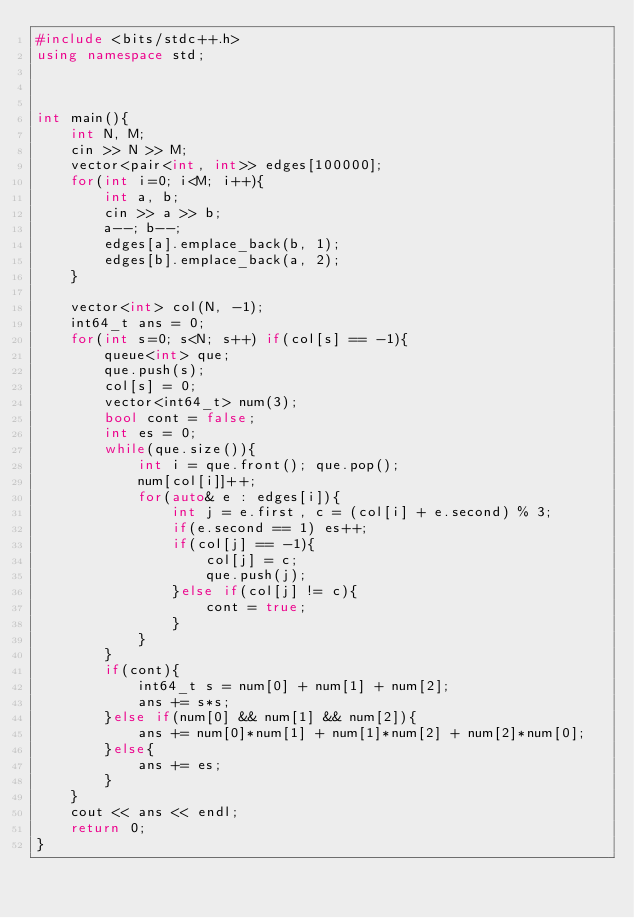Convert code to text. <code><loc_0><loc_0><loc_500><loc_500><_C++_>#include <bits/stdc++.h>
using namespace std;



int main(){
    int N, M;
    cin >> N >> M;
    vector<pair<int, int>> edges[100000];
    for(int i=0; i<M; i++){
        int a, b;
        cin >> a >> b;
        a--; b--;
        edges[a].emplace_back(b, 1);
        edges[b].emplace_back(a, 2);
    }

    vector<int> col(N, -1);
    int64_t ans = 0;
    for(int s=0; s<N; s++) if(col[s] == -1){
        queue<int> que;
        que.push(s);
        col[s] = 0;
        vector<int64_t> num(3);
        bool cont = false;
        int es = 0;
        while(que.size()){
            int i = que.front(); que.pop();
            num[col[i]]++;
            for(auto& e : edges[i]){
                int j = e.first, c = (col[i] + e.second) % 3;
                if(e.second == 1) es++;
                if(col[j] == -1){
                    col[j] = c;
                    que.push(j);
                }else if(col[j] != c){
                    cont = true;
                }
            }
        }
        if(cont){
            int64_t s = num[0] + num[1] + num[2];
            ans += s*s;
        }else if(num[0] && num[1] && num[2]){
            ans += num[0]*num[1] + num[1]*num[2] + num[2]*num[0];
        }else{
            ans += es;
        }
    }
    cout << ans << endl;
    return 0;
}
</code> 